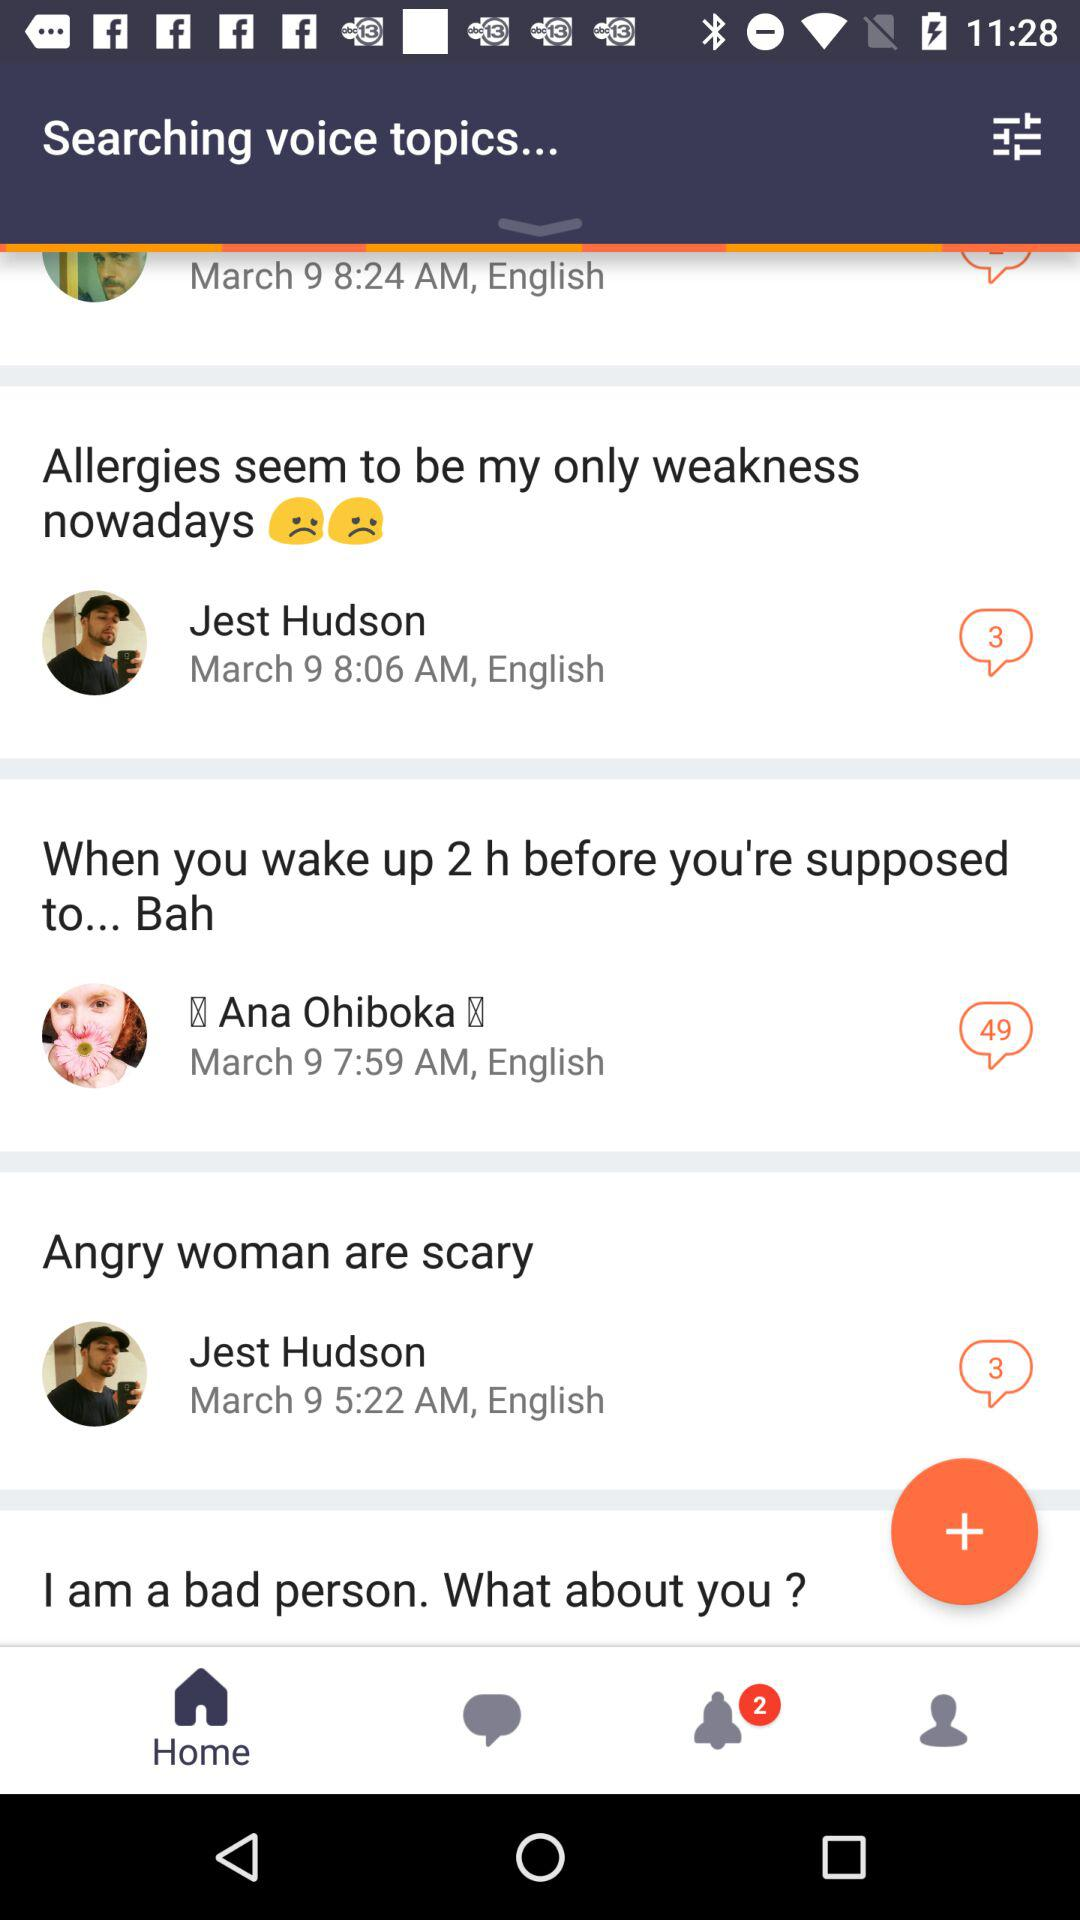In what language are the comments posted? The comments are posted in "English". 